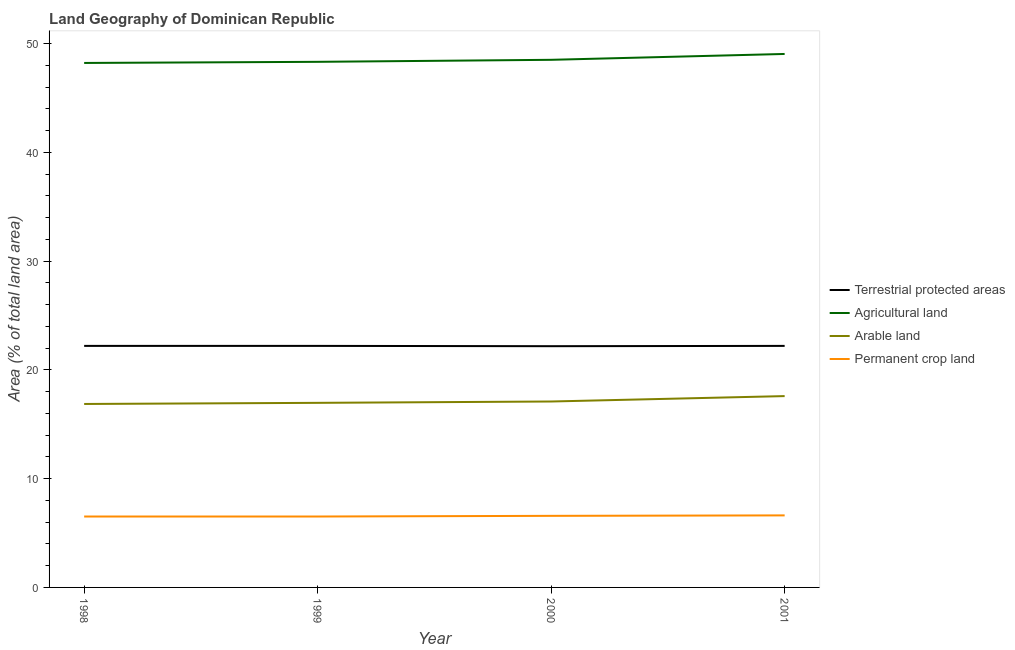Does the line corresponding to percentage of area under arable land intersect with the line corresponding to percentage of area under permanent crop land?
Provide a succinct answer. No. What is the percentage of land under terrestrial protection in 2001?
Make the answer very short. 22.21. Across all years, what is the maximum percentage of area under permanent crop land?
Ensure brevity in your answer.  6.62. Across all years, what is the minimum percentage of area under arable land?
Provide a short and direct response. 16.87. What is the total percentage of area under permanent crop land in the graph?
Your answer should be compact. 26.24. What is the difference between the percentage of area under agricultural land in 1998 and that in 1999?
Ensure brevity in your answer.  -0.1. What is the difference between the percentage of area under agricultural land in 2001 and the percentage of area under permanent crop land in 1999?
Make the answer very short. 42.53. What is the average percentage of area under permanent crop land per year?
Provide a short and direct response. 6.56. In the year 1998, what is the difference between the percentage of area under permanent crop land and percentage of area under arable land?
Provide a short and direct response. -10.35. What is the ratio of the percentage of area under agricultural land in 1999 to that in 2000?
Provide a short and direct response. 1. What is the difference between the highest and the second highest percentage of area under permanent crop land?
Provide a succinct answer. 0.04. What is the difference between the highest and the lowest percentage of land under terrestrial protection?
Provide a succinct answer. 0.03. In how many years, is the percentage of area under permanent crop land greater than the average percentage of area under permanent crop land taken over all years?
Provide a succinct answer. 2. Is it the case that in every year, the sum of the percentage of land under terrestrial protection and percentage of area under permanent crop land is greater than the sum of percentage of area under agricultural land and percentage of area under arable land?
Ensure brevity in your answer.  Yes. Is it the case that in every year, the sum of the percentage of land under terrestrial protection and percentage of area under agricultural land is greater than the percentage of area under arable land?
Ensure brevity in your answer.  Yes. Is the percentage of area under permanent crop land strictly less than the percentage of area under agricultural land over the years?
Give a very brief answer. Yes. How many years are there in the graph?
Provide a succinct answer. 4. What is the difference between two consecutive major ticks on the Y-axis?
Provide a succinct answer. 10. Are the values on the major ticks of Y-axis written in scientific E-notation?
Your response must be concise. No. Where does the legend appear in the graph?
Your answer should be compact. Center right. What is the title of the graph?
Make the answer very short. Land Geography of Dominican Republic. What is the label or title of the X-axis?
Provide a succinct answer. Year. What is the label or title of the Y-axis?
Your answer should be compact. Area (% of total land area). What is the Area (% of total land area) in Terrestrial protected areas in 1998?
Ensure brevity in your answer.  22.21. What is the Area (% of total land area) of Agricultural land in 1998?
Give a very brief answer. 48.22. What is the Area (% of total land area) in Arable land in 1998?
Your answer should be very brief. 16.87. What is the Area (% of total land area) in Permanent crop land in 1998?
Your answer should be compact. 6.52. What is the Area (% of total land area) in Terrestrial protected areas in 1999?
Keep it short and to the point. 22.21. What is the Area (% of total land area) in Agricultural land in 1999?
Offer a very short reply. 48.32. What is the Area (% of total land area) in Arable land in 1999?
Give a very brief answer. 16.97. What is the Area (% of total land area) of Permanent crop land in 1999?
Your response must be concise. 6.52. What is the Area (% of total land area) in Terrestrial protected areas in 2000?
Keep it short and to the point. 22.18. What is the Area (% of total land area) of Agricultural land in 2000?
Your answer should be very brief. 48.51. What is the Area (% of total land area) of Arable land in 2000?
Make the answer very short. 17.09. What is the Area (% of total land area) in Permanent crop land in 2000?
Give a very brief answer. 6.58. What is the Area (% of total land area) in Terrestrial protected areas in 2001?
Provide a short and direct response. 22.21. What is the Area (% of total land area) in Agricultural land in 2001?
Provide a succinct answer. 49.05. What is the Area (% of total land area) of Arable land in 2001?
Provide a short and direct response. 17.59. What is the Area (% of total land area) of Permanent crop land in 2001?
Provide a succinct answer. 6.62. Across all years, what is the maximum Area (% of total land area) of Terrestrial protected areas?
Your response must be concise. 22.21. Across all years, what is the maximum Area (% of total land area) of Agricultural land?
Provide a short and direct response. 49.05. Across all years, what is the maximum Area (% of total land area) of Arable land?
Your answer should be compact. 17.59. Across all years, what is the maximum Area (% of total land area) of Permanent crop land?
Provide a short and direct response. 6.62. Across all years, what is the minimum Area (% of total land area) of Terrestrial protected areas?
Your answer should be very brief. 22.18. Across all years, what is the minimum Area (% of total land area) in Agricultural land?
Make the answer very short. 48.22. Across all years, what is the minimum Area (% of total land area) in Arable land?
Your answer should be compact. 16.87. Across all years, what is the minimum Area (% of total land area) in Permanent crop land?
Make the answer very short. 6.52. What is the total Area (% of total land area) of Terrestrial protected areas in the graph?
Provide a short and direct response. 88.8. What is the total Area (% of total land area) of Agricultural land in the graph?
Your response must be concise. 194.1. What is the total Area (% of total land area) in Arable land in the graph?
Keep it short and to the point. 68.52. What is the total Area (% of total land area) in Permanent crop land in the graph?
Ensure brevity in your answer.  26.24. What is the difference between the Area (% of total land area) of Agricultural land in 1998 and that in 1999?
Make the answer very short. -0.1. What is the difference between the Area (% of total land area) of Arable land in 1998 and that in 1999?
Give a very brief answer. -0.1. What is the difference between the Area (% of total land area) of Permanent crop land in 1998 and that in 1999?
Keep it short and to the point. 0. What is the difference between the Area (% of total land area) in Terrestrial protected areas in 1998 and that in 2000?
Your response must be concise. 0.03. What is the difference between the Area (% of total land area) of Agricultural land in 1998 and that in 2000?
Make the answer very short. -0.29. What is the difference between the Area (% of total land area) of Arable land in 1998 and that in 2000?
Your answer should be very brief. -0.23. What is the difference between the Area (% of total land area) of Permanent crop land in 1998 and that in 2000?
Offer a very short reply. -0.06. What is the difference between the Area (% of total land area) of Agricultural land in 1998 and that in 2001?
Provide a short and direct response. -0.83. What is the difference between the Area (% of total land area) in Arable land in 1998 and that in 2001?
Offer a terse response. -0.72. What is the difference between the Area (% of total land area) in Permanent crop land in 1998 and that in 2001?
Offer a very short reply. -0.1. What is the difference between the Area (% of total land area) of Terrestrial protected areas in 1999 and that in 2000?
Your response must be concise. 0.03. What is the difference between the Area (% of total land area) of Agricultural land in 1999 and that in 2000?
Your response must be concise. -0.19. What is the difference between the Area (% of total land area) of Arable land in 1999 and that in 2000?
Keep it short and to the point. -0.12. What is the difference between the Area (% of total land area) in Permanent crop land in 1999 and that in 2000?
Provide a short and direct response. -0.06. What is the difference between the Area (% of total land area) in Terrestrial protected areas in 1999 and that in 2001?
Keep it short and to the point. 0. What is the difference between the Area (% of total land area) in Agricultural land in 1999 and that in 2001?
Give a very brief answer. -0.72. What is the difference between the Area (% of total land area) in Arable land in 1999 and that in 2001?
Give a very brief answer. -0.62. What is the difference between the Area (% of total land area) in Permanent crop land in 1999 and that in 2001?
Keep it short and to the point. -0.1. What is the difference between the Area (% of total land area) in Terrestrial protected areas in 2000 and that in 2001?
Give a very brief answer. -0.03. What is the difference between the Area (% of total land area) of Agricultural land in 2000 and that in 2001?
Provide a short and direct response. -0.54. What is the difference between the Area (% of total land area) of Arable land in 2000 and that in 2001?
Ensure brevity in your answer.  -0.5. What is the difference between the Area (% of total land area) of Permanent crop land in 2000 and that in 2001?
Your answer should be very brief. -0.04. What is the difference between the Area (% of total land area) of Terrestrial protected areas in 1998 and the Area (% of total land area) of Agricultural land in 1999?
Provide a short and direct response. -26.12. What is the difference between the Area (% of total land area) in Terrestrial protected areas in 1998 and the Area (% of total land area) in Arable land in 1999?
Make the answer very short. 5.24. What is the difference between the Area (% of total land area) of Terrestrial protected areas in 1998 and the Area (% of total land area) of Permanent crop land in 1999?
Keep it short and to the point. 15.69. What is the difference between the Area (% of total land area) of Agricultural land in 1998 and the Area (% of total land area) of Arable land in 1999?
Give a very brief answer. 31.25. What is the difference between the Area (% of total land area) in Agricultural land in 1998 and the Area (% of total land area) in Permanent crop land in 1999?
Your response must be concise. 41.7. What is the difference between the Area (% of total land area) in Arable land in 1998 and the Area (% of total land area) in Permanent crop land in 1999?
Offer a terse response. 10.35. What is the difference between the Area (% of total land area) in Terrestrial protected areas in 1998 and the Area (% of total land area) in Agricultural land in 2000?
Offer a terse response. -26.3. What is the difference between the Area (% of total land area) in Terrestrial protected areas in 1998 and the Area (% of total land area) in Arable land in 2000?
Your response must be concise. 5.11. What is the difference between the Area (% of total land area) of Terrestrial protected areas in 1998 and the Area (% of total land area) of Permanent crop land in 2000?
Provide a short and direct response. 15.63. What is the difference between the Area (% of total land area) of Agricultural land in 1998 and the Area (% of total land area) of Arable land in 2000?
Your answer should be compact. 31.13. What is the difference between the Area (% of total land area) of Agricultural land in 1998 and the Area (% of total land area) of Permanent crop land in 2000?
Provide a succinct answer. 41.64. What is the difference between the Area (% of total land area) of Arable land in 1998 and the Area (% of total land area) of Permanent crop land in 2000?
Make the answer very short. 10.29. What is the difference between the Area (% of total land area) of Terrestrial protected areas in 1998 and the Area (% of total land area) of Agricultural land in 2001?
Keep it short and to the point. -26.84. What is the difference between the Area (% of total land area) of Terrestrial protected areas in 1998 and the Area (% of total land area) of Arable land in 2001?
Provide a short and direct response. 4.62. What is the difference between the Area (% of total land area) in Terrestrial protected areas in 1998 and the Area (% of total land area) in Permanent crop land in 2001?
Ensure brevity in your answer.  15.58. What is the difference between the Area (% of total land area) of Agricultural land in 1998 and the Area (% of total land area) of Arable land in 2001?
Offer a terse response. 30.63. What is the difference between the Area (% of total land area) of Agricultural land in 1998 and the Area (% of total land area) of Permanent crop land in 2001?
Give a very brief answer. 41.6. What is the difference between the Area (% of total land area) of Arable land in 1998 and the Area (% of total land area) of Permanent crop land in 2001?
Offer a very short reply. 10.24. What is the difference between the Area (% of total land area) of Terrestrial protected areas in 1999 and the Area (% of total land area) of Agricultural land in 2000?
Your answer should be compact. -26.3. What is the difference between the Area (% of total land area) of Terrestrial protected areas in 1999 and the Area (% of total land area) of Arable land in 2000?
Provide a short and direct response. 5.11. What is the difference between the Area (% of total land area) in Terrestrial protected areas in 1999 and the Area (% of total land area) in Permanent crop land in 2000?
Provide a succinct answer. 15.63. What is the difference between the Area (% of total land area) in Agricultural land in 1999 and the Area (% of total land area) in Arable land in 2000?
Give a very brief answer. 31.23. What is the difference between the Area (% of total land area) in Agricultural land in 1999 and the Area (% of total land area) in Permanent crop land in 2000?
Keep it short and to the point. 41.74. What is the difference between the Area (% of total land area) in Arable land in 1999 and the Area (% of total land area) in Permanent crop land in 2000?
Ensure brevity in your answer.  10.39. What is the difference between the Area (% of total land area) in Terrestrial protected areas in 1999 and the Area (% of total land area) in Agricultural land in 2001?
Provide a succinct answer. -26.84. What is the difference between the Area (% of total land area) in Terrestrial protected areas in 1999 and the Area (% of total land area) in Arable land in 2001?
Ensure brevity in your answer.  4.62. What is the difference between the Area (% of total land area) of Terrestrial protected areas in 1999 and the Area (% of total land area) of Permanent crop land in 2001?
Provide a succinct answer. 15.58. What is the difference between the Area (% of total land area) of Agricultural land in 1999 and the Area (% of total land area) of Arable land in 2001?
Make the answer very short. 30.73. What is the difference between the Area (% of total land area) of Agricultural land in 1999 and the Area (% of total land area) of Permanent crop land in 2001?
Provide a short and direct response. 41.7. What is the difference between the Area (% of total land area) of Arable land in 1999 and the Area (% of total land area) of Permanent crop land in 2001?
Your answer should be very brief. 10.35. What is the difference between the Area (% of total land area) in Terrestrial protected areas in 2000 and the Area (% of total land area) in Agricultural land in 2001?
Provide a succinct answer. -26.87. What is the difference between the Area (% of total land area) in Terrestrial protected areas in 2000 and the Area (% of total land area) in Arable land in 2001?
Keep it short and to the point. 4.59. What is the difference between the Area (% of total land area) in Terrestrial protected areas in 2000 and the Area (% of total land area) in Permanent crop land in 2001?
Offer a terse response. 15.56. What is the difference between the Area (% of total land area) in Agricultural land in 2000 and the Area (% of total land area) in Arable land in 2001?
Offer a very short reply. 30.92. What is the difference between the Area (% of total land area) in Agricultural land in 2000 and the Area (% of total land area) in Permanent crop land in 2001?
Provide a succinct answer. 41.89. What is the difference between the Area (% of total land area) in Arable land in 2000 and the Area (% of total land area) in Permanent crop land in 2001?
Your answer should be very brief. 10.47. What is the average Area (% of total land area) of Terrestrial protected areas per year?
Your answer should be compact. 22.2. What is the average Area (% of total land area) of Agricultural land per year?
Give a very brief answer. 48.53. What is the average Area (% of total land area) of Arable land per year?
Offer a terse response. 17.13. What is the average Area (% of total land area) in Permanent crop land per year?
Make the answer very short. 6.56. In the year 1998, what is the difference between the Area (% of total land area) of Terrestrial protected areas and Area (% of total land area) of Agricultural land?
Provide a short and direct response. -26.01. In the year 1998, what is the difference between the Area (% of total land area) of Terrestrial protected areas and Area (% of total land area) of Arable land?
Your answer should be compact. 5.34. In the year 1998, what is the difference between the Area (% of total land area) in Terrestrial protected areas and Area (% of total land area) in Permanent crop land?
Give a very brief answer. 15.69. In the year 1998, what is the difference between the Area (% of total land area) of Agricultural land and Area (% of total land area) of Arable land?
Your response must be concise. 31.35. In the year 1998, what is the difference between the Area (% of total land area) of Agricultural land and Area (% of total land area) of Permanent crop land?
Offer a terse response. 41.7. In the year 1998, what is the difference between the Area (% of total land area) of Arable land and Area (% of total land area) of Permanent crop land?
Keep it short and to the point. 10.35. In the year 1999, what is the difference between the Area (% of total land area) in Terrestrial protected areas and Area (% of total land area) in Agricultural land?
Your answer should be compact. -26.12. In the year 1999, what is the difference between the Area (% of total land area) of Terrestrial protected areas and Area (% of total land area) of Arable land?
Make the answer very short. 5.24. In the year 1999, what is the difference between the Area (% of total land area) in Terrestrial protected areas and Area (% of total land area) in Permanent crop land?
Offer a terse response. 15.69. In the year 1999, what is the difference between the Area (% of total land area) in Agricultural land and Area (% of total land area) in Arable land?
Your response must be concise. 31.35. In the year 1999, what is the difference between the Area (% of total land area) in Agricultural land and Area (% of total land area) in Permanent crop land?
Your response must be concise. 41.8. In the year 1999, what is the difference between the Area (% of total land area) in Arable land and Area (% of total land area) in Permanent crop land?
Your answer should be compact. 10.45. In the year 2000, what is the difference between the Area (% of total land area) in Terrestrial protected areas and Area (% of total land area) in Agricultural land?
Your answer should be very brief. -26.33. In the year 2000, what is the difference between the Area (% of total land area) in Terrestrial protected areas and Area (% of total land area) in Arable land?
Offer a terse response. 5.09. In the year 2000, what is the difference between the Area (% of total land area) of Terrestrial protected areas and Area (% of total land area) of Permanent crop land?
Ensure brevity in your answer.  15.6. In the year 2000, what is the difference between the Area (% of total land area) in Agricultural land and Area (% of total land area) in Arable land?
Your answer should be compact. 31.42. In the year 2000, what is the difference between the Area (% of total land area) in Agricultural land and Area (% of total land area) in Permanent crop land?
Your answer should be compact. 41.93. In the year 2000, what is the difference between the Area (% of total land area) in Arable land and Area (% of total land area) in Permanent crop land?
Your response must be concise. 10.51. In the year 2001, what is the difference between the Area (% of total land area) of Terrestrial protected areas and Area (% of total land area) of Agricultural land?
Provide a short and direct response. -26.84. In the year 2001, what is the difference between the Area (% of total land area) of Terrestrial protected areas and Area (% of total land area) of Arable land?
Offer a terse response. 4.62. In the year 2001, what is the difference between the Area (% of total land area) in Terrestrial protected areas and Area (% of total land area) in Permanent crop land?
Ensure brevity in your answer.  15.58. In the year 2001, what is the difference between the Area (% of total land area) in Agricultural land and Area (% of total land area) in Arable land?
Your answer should be very brief. 31.46. In the year 2001, what is the difference between the Area (% of total land area) of Agricultural land and Area (% of total land area) of Permanent crop land?
Give a very brief answer. 42.43. In the year 2001, what is the difference between the Area (% of total land area) in Arable land and Area (% of total land area) in Permanent crop land?
Your answer should be compact. 10.97. What is the ratio of the Area (% of total land area) in Agricultural land in 1998 to that in 1999?
Offer a very short reply. 1. What is the ratio of the Area (% of total land area) of Permanent crop land in 1998 to that in 1999?
Offer a very short reply. 1. What is the ratio of the Area (% of total land area) of Terrestrial protected areas in 1998 to that in 2000?
Provide a succinct answer. 1. What is the ratio of the Area (% of total land area) of Arable land in 1998 to that in 2000?
Make the answer very short. 0.99. What is the ratio of the Area (% of total land area) of Permanent crop land in 1998 to that in 2000?
Your answer should be very brief. 0.99. What is the ratio of the Area (% of total land area) in Agricultural land in 1998 to that in 2001?
Your response must be concise. 0.98. What is the ratio of the Area (% of total land area) of Arable land in 1998 to that in 2001?
Your answer should be compact. 0.96. What is the ratio of the Area (% of total land area) of Permanent crop land in 1998 to that in 2001?
Provide a short and direct response. 0.98. What is the ratio of the Area (% of total land area) in Arable land in 1999 to that in 2000?
Your answer should be very brief. 0.99. What is the ratio of the Area (% of total land area) of Permanent crop land in 1999 to that in 2000?
Make the answer very short. 0.99. What is the ratio of the Area (% of total land area) of Terrestrial protected areas in 1999 to that in 2001?
Make the answer very short. 1. What is the ratio of the Area (% of total land area) of Agricultural land in 1999 to that in 2001?
Offer a terse response. 0.99. What is the ratio of the Area (% of total land area) of Arable land in 1999 to that in 2001?
Your response must be concise. 0.96. What is the ratio of the Area (% of total land area) in Permanent crop land in 1999 to that in 2001?
Make the answer very short. 0.98. What is the ratio of the Area (% of total land area) in Terrestrial protected areas in 2000 to that in 2001?
Ensure brevity in your answer.  1. What is the ratio of the Area (% of total land area) of Arable land in 2000 to that in 2001?
Offer a terse response. 0.97. What is the difference between the highest and the second highest Area (% of total land area) of Agricultural land?
Provide a succinct answer. 0.54. What is the difference between the highest and the second highest Area (% of total land area) of Arable land?
Offer a very short reply. 0.5. What is the difference between the highest and the second highest Area (% of total land area) of Permanent crop land?
Give a very brief answer. 0.04. What is the difference between the highest and the lowest Area (% of total land area) of Terrestrial protected areas?
Give a very brief answer. 0.03. What is the difference between the highest and the lowest Area (% of total land area) of Agricultural land?
Offer a terse response. 0.83. What is the difference between the highest and the lowest Area (% of total land area) in Arable land?
Your answer should be compact. 0.72. What is the difference between the highest and the lowest Area (% of total land area) in Permanent crop land?
Provide a short and direct response. 0.1. 